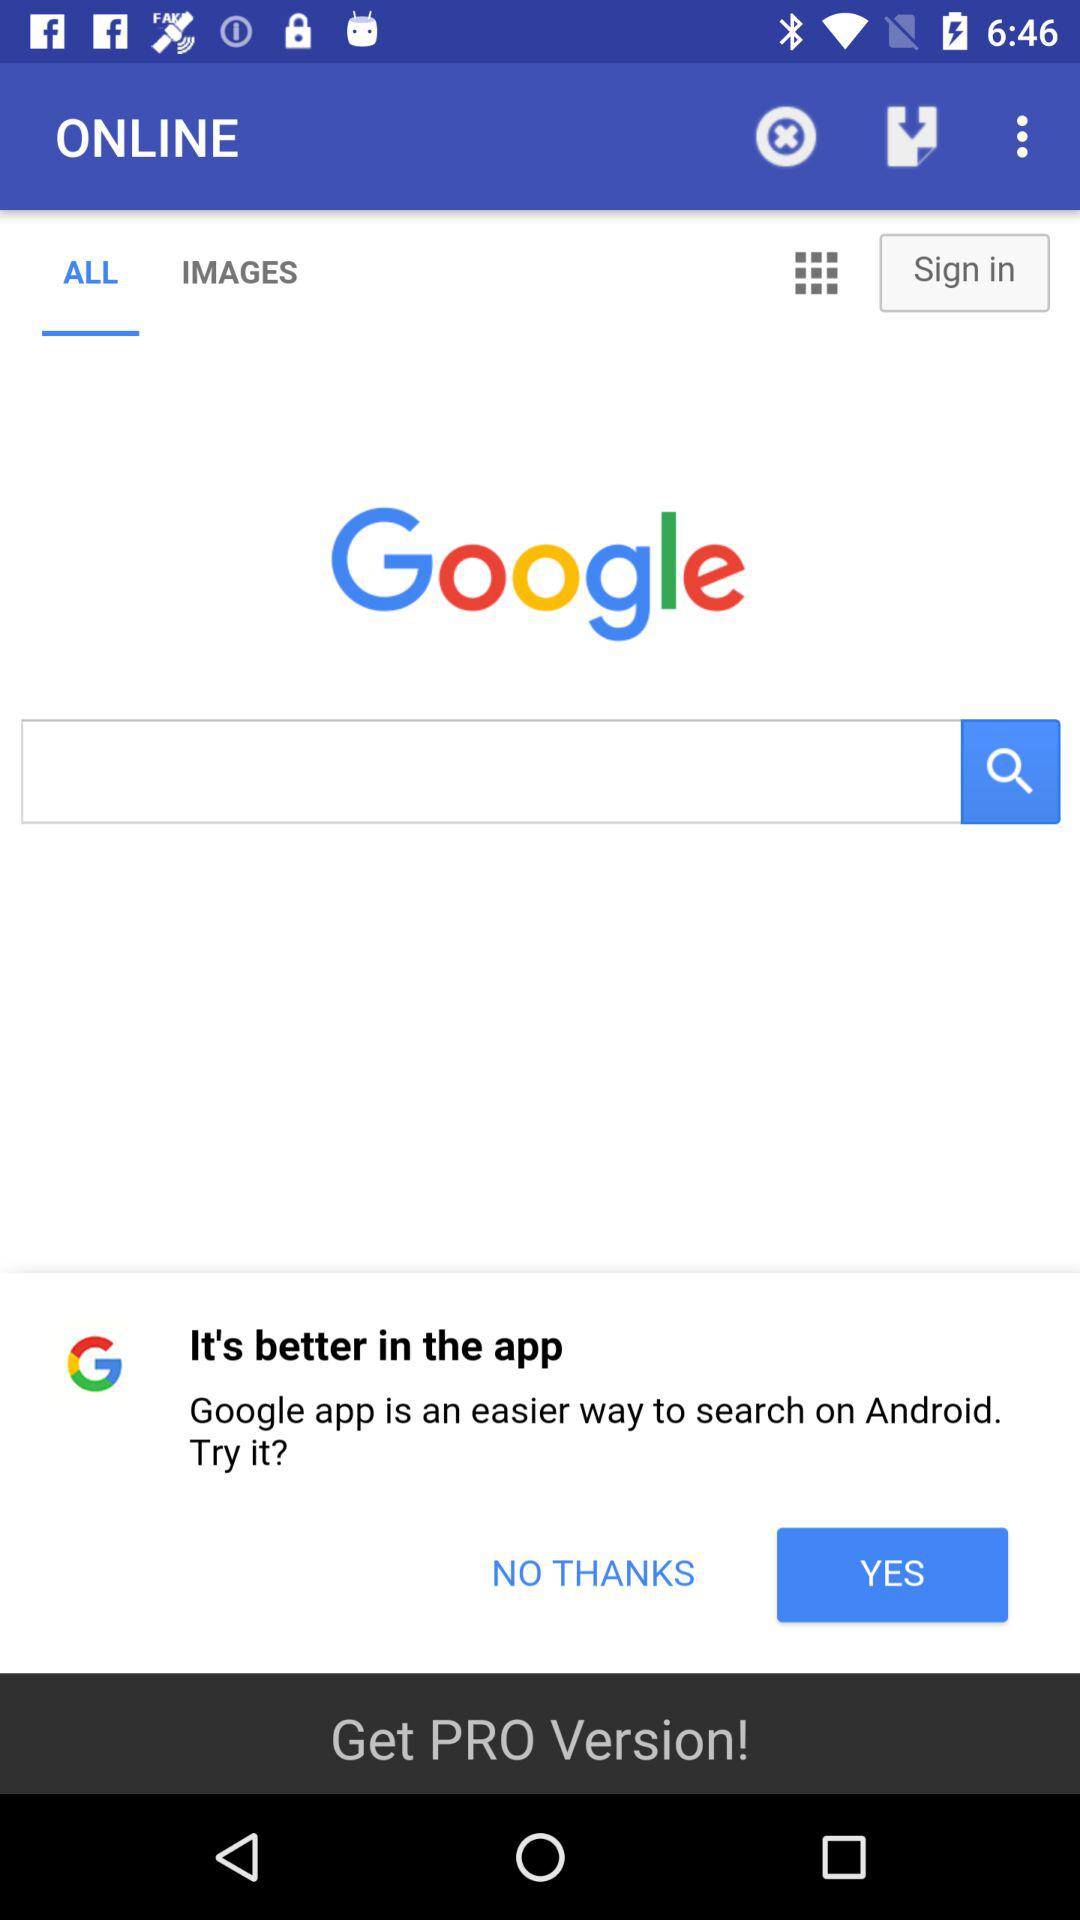Which tab is selected? The selected tab is "ALL". 